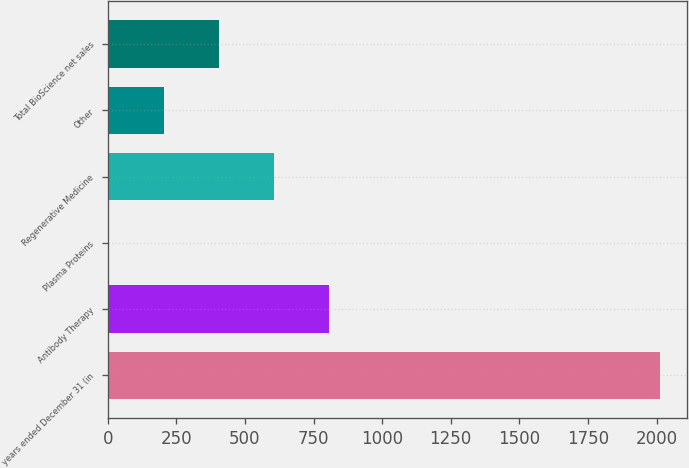Convert chart to OTSL. <chart><loc_0><loc_0><loc_500><loc_500><bar_chart><fcel>years ended December 31 (in<fcel>Antibody Therapy<fcel>Plasma Proteins<fcel>Regenerative Medicine<fcel>Other<fcel>Total BioScience net sales<nl><fcel>2011<fcel>807.4<fcel>5<fcel>606.8<fcel>205.6<fcel>406.2<nl></chart> 